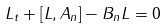<formula> <loc_0><loc_0><loc_500><loc_500>L _ { t } + [ L , A _ { n } ] - B _ { n } L = 0</formula> 